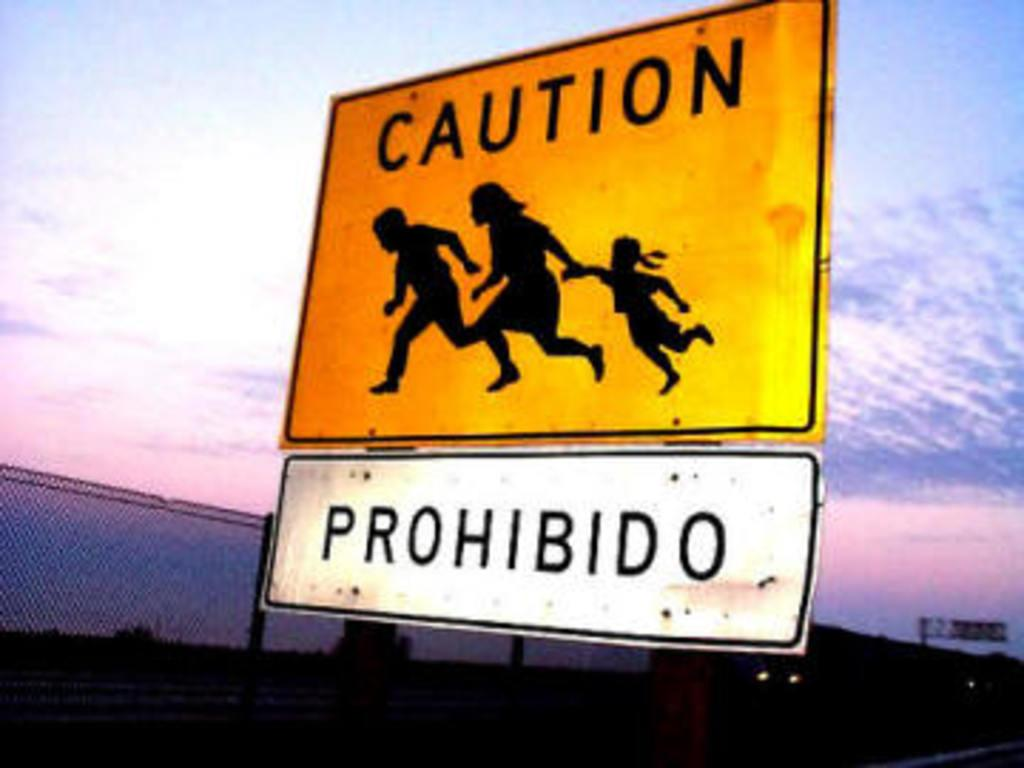<image>
Create a compact narrative representing the image presented. A bright yellow street sign has images of a man, woman, and child running with a whited sign that says prohibited in Spanish, underneath. 